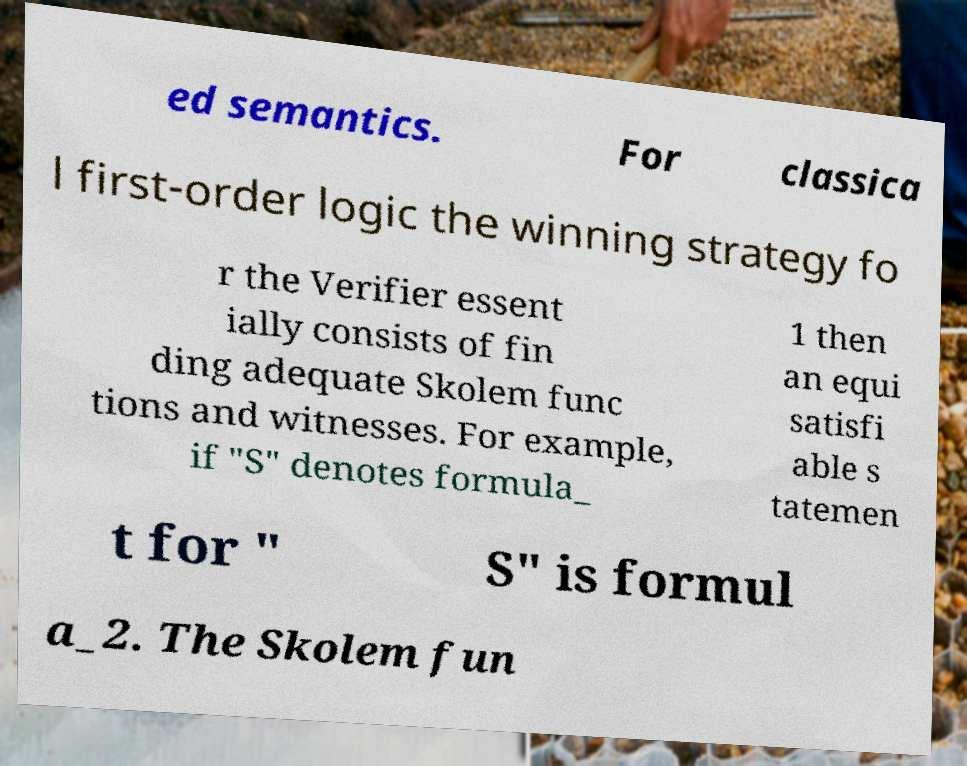For documentation purposes, I need the text within this image transcribed. Could you provide that? ed semantics. For classica l first-order logic the winning strategy fo r the Verifier essent ially consists of fin ding adequate Skolem func tions and witnesses. For example, if "S" denotes formula_ 1 then an equi satisfi able s tatemen t for " S" is formul a_2. The Skolem fun 